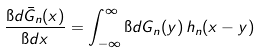<formula> <loc_0><loc_0><loc_500><loc_500>\frac { \i d \bar { G } _ { n } ( x ) } { \i d x } = \int _ { - \infty } ^ { \infty } \i d G _ { n } ( y ) \, h _ { n } ( x - y )</formula> 